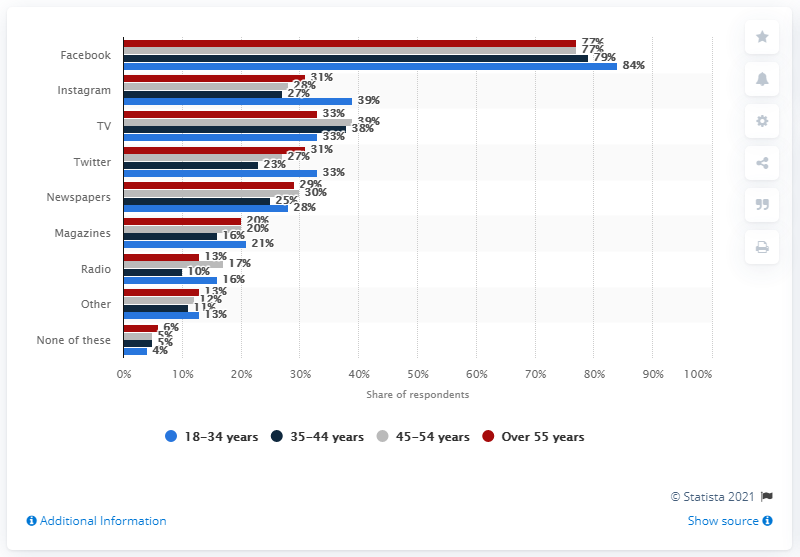Highlight a few significant elements in this photo. According to a recent survey, a significant percentage of Italians believe that radio is a source of misinformation or fake news about the COVID-19 pandemic. 